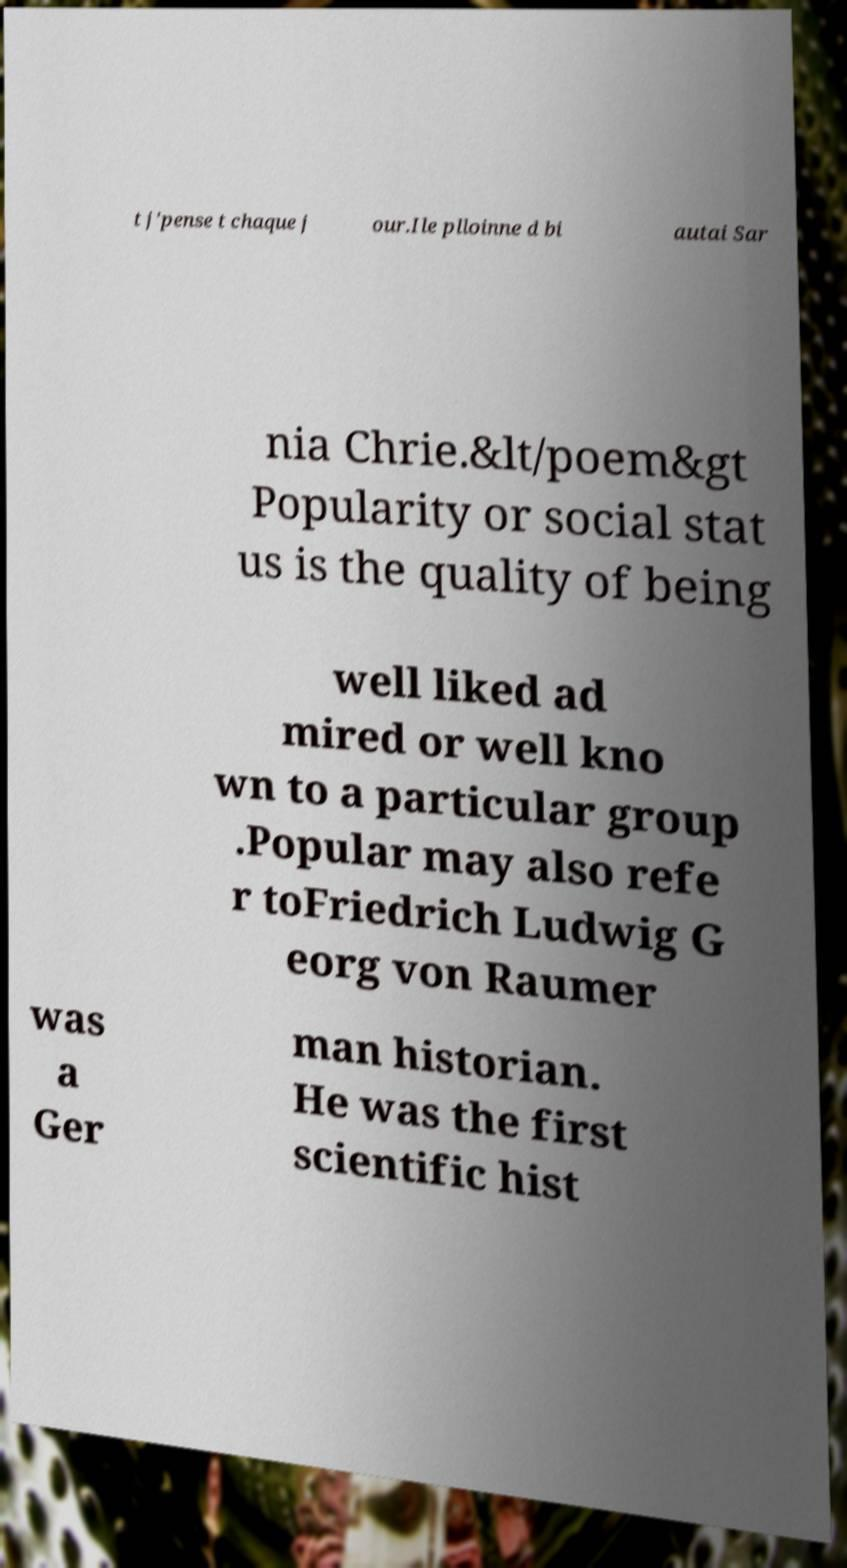Please identify and transcribe the text found in this image. t j'pense t chaque j our.Ile plloinne d bi autai Sar nia Chrie.&lt/poem&gt Popularity or social stat us is the quality of being well liked ad mired or well kno wn to a particular group .Popular may also refe r toFriedrich Ludwig G eorg von Raumer was a Ger man historian. He was the first scientific hist 